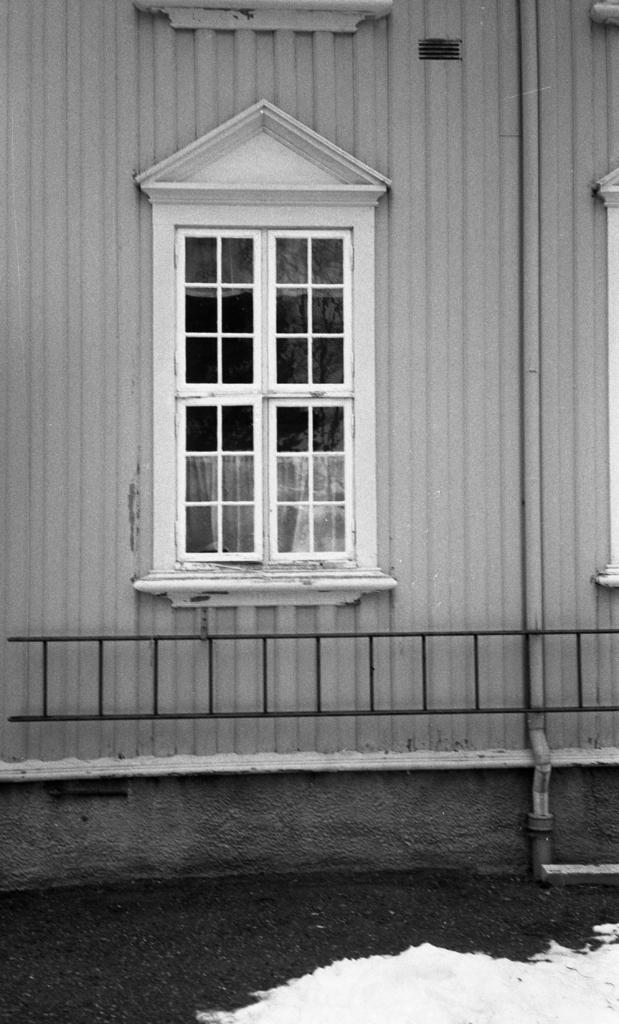What is the color scheme of the image? The image is black and white. What type of structure is present in the image? There is a building in the image. What feature can be seen on the building? The building has a window. What other object is visible in the image? There is a pole in the image. What type of barrier is present in the image? There is a grille in the image. What type of orange machine is visible in the image? There is no orange machine present in the image. 